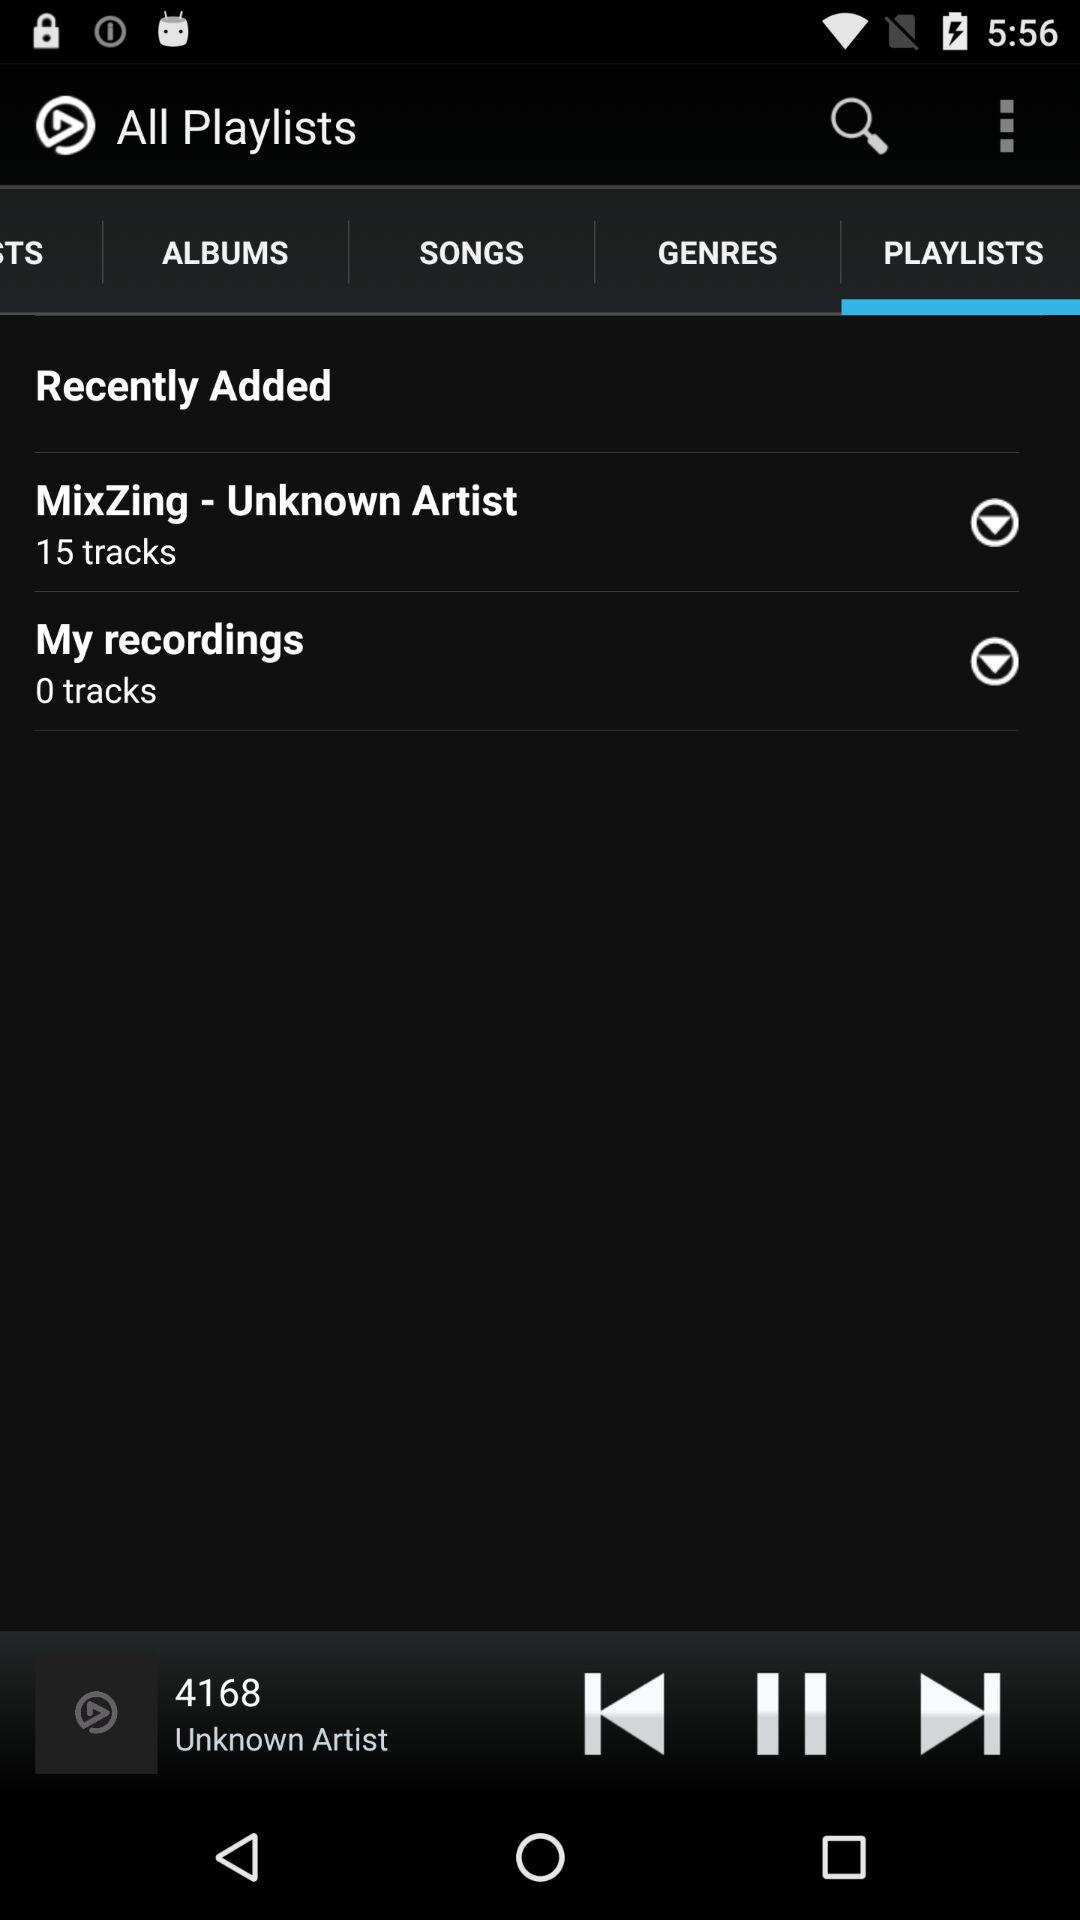How many tracks are there in MixZing? There are 15 track in MixZing. 